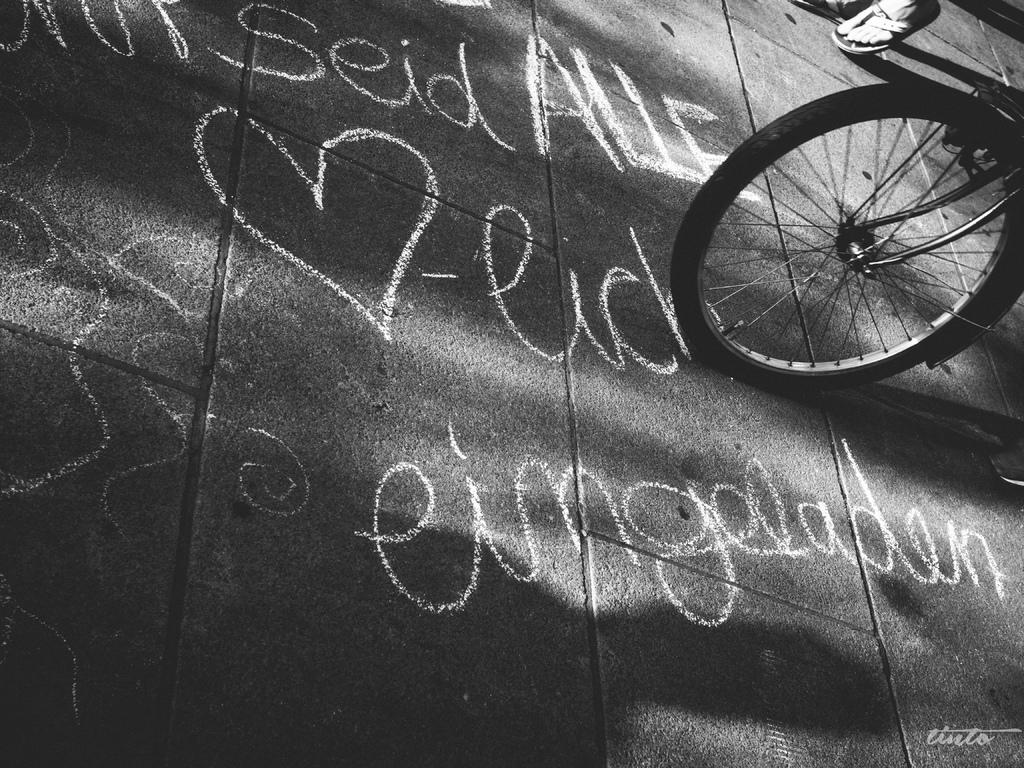What are the two activities being performed by people in the image? There is a person walking on the road and another person riding a bicycle on the road. What is written on the road? There is text on the road. How many chairs can be seen in the image? There are no chairs present in the image. What is the range of the route being taken by the person walking in the image? The facts provided do not give information about the route or its range, so we cannot determine that from the image. 